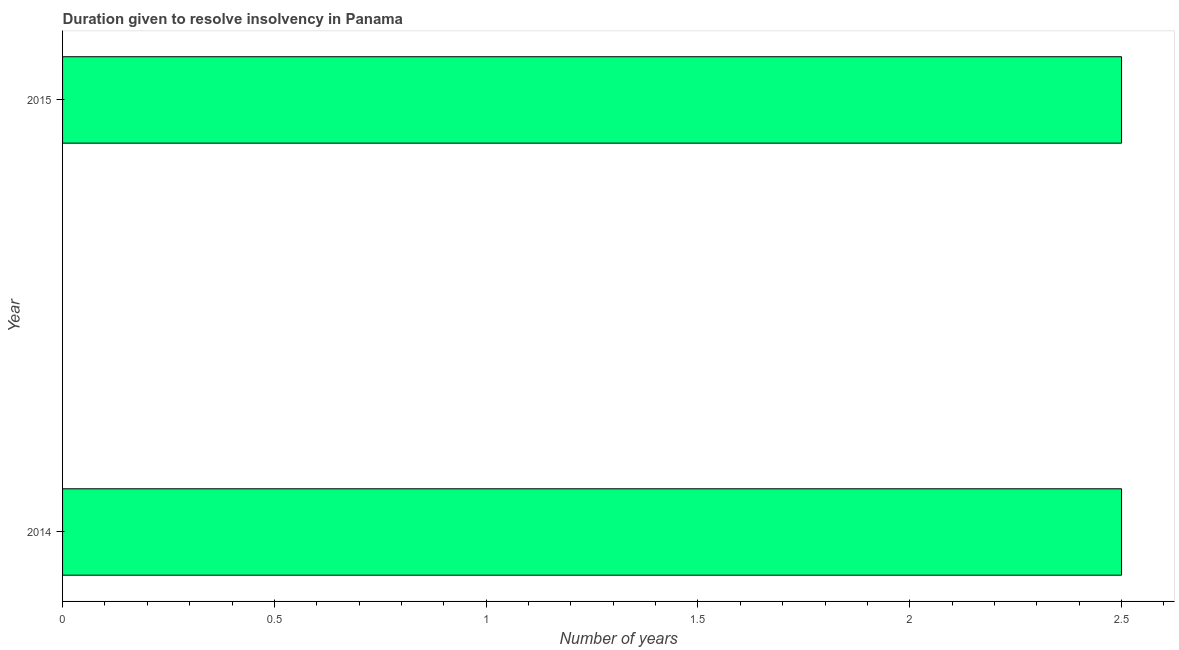Does the graph contain any zero values?
Your response must be concise. No. Does the graph contain grids?
Your answer should be very brief. No. What is the title of the graph?
Offer a terse response. Duration given to resolve insolvency in Panama. What is the label or title of the X-axis?
Make the answer very short. Number of years. Across all years, what is the minimum number of years to resolve insolvency?
Provide a short and direct response. 2.5. In which year was the number of years to resolve insolvency maximum?
Your response must be concise. 2014. In which year was the number of years to resolve insolvency minimum?
Ensure brevity in your answer.  2014. What is the sum of the number of years to resolve insolvency?
Ensure brevity in your answer.  5. What is the median number of years to resolve insolvency?
Your response must be concise. 2.5. What is the ratio of the number of years to resolve insolvency in 2014 to that in 2015?
Provide a succinct answer. 1. Is the number of years to resolve insolvency in 2014 less than that in 2015?
Your response must be concise. No. In how many years, is the number of years to resolve insolvency greater than the average number of years to resolve insolvency taken over all years?
Offer a terse response. 0. How many bars are there?
Make the answer very short. 2. How many years are there in the graph?
Provide a succinct answer. 2. Are the values on the major ticks of X-axis written in scientific E-notation?
Your response must be concise. No. What is the Number of years of 2015?
Make the answer very short. 2.5. 